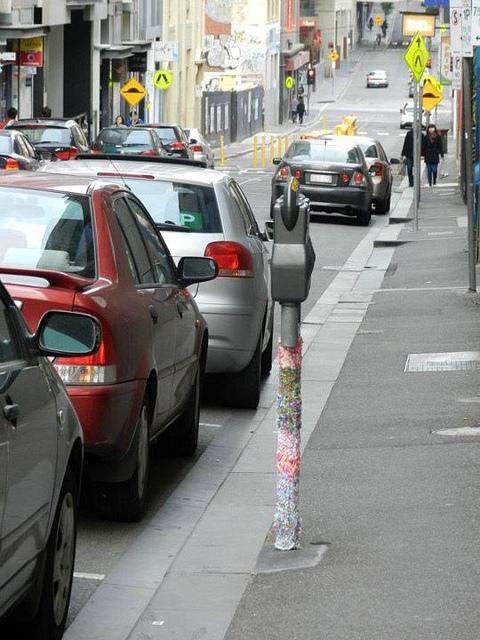How many cars are in the photo?
Give a very brief answer. 5. How many yellow boats are there?
Give a very brief answer. 0. 